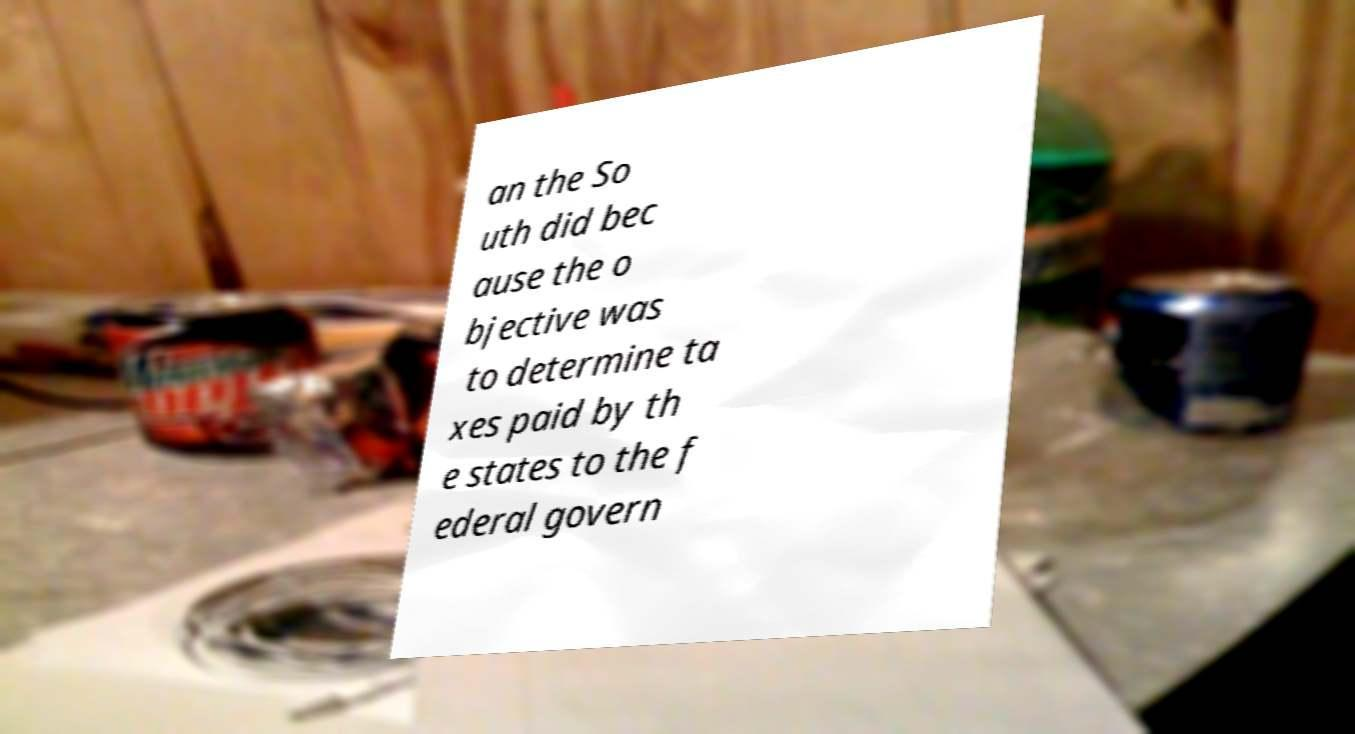For documentation purposes, I need the text within this image transcribed. Could you provide that? an the So uth did bec ause the o bjective was to determine ta xes paid by th e states to the f ederal govern 